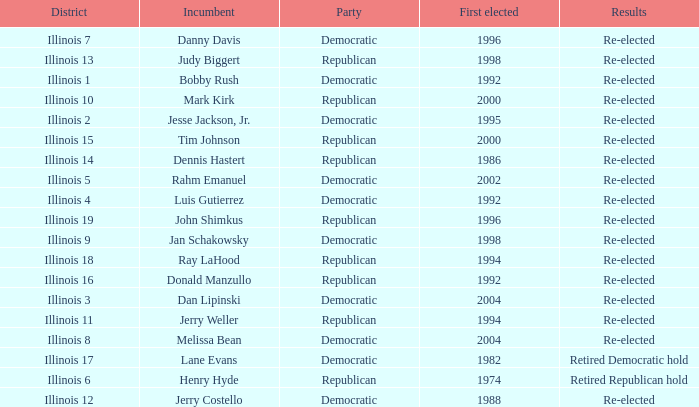What is Illinois 13 District's Party? Republican. 